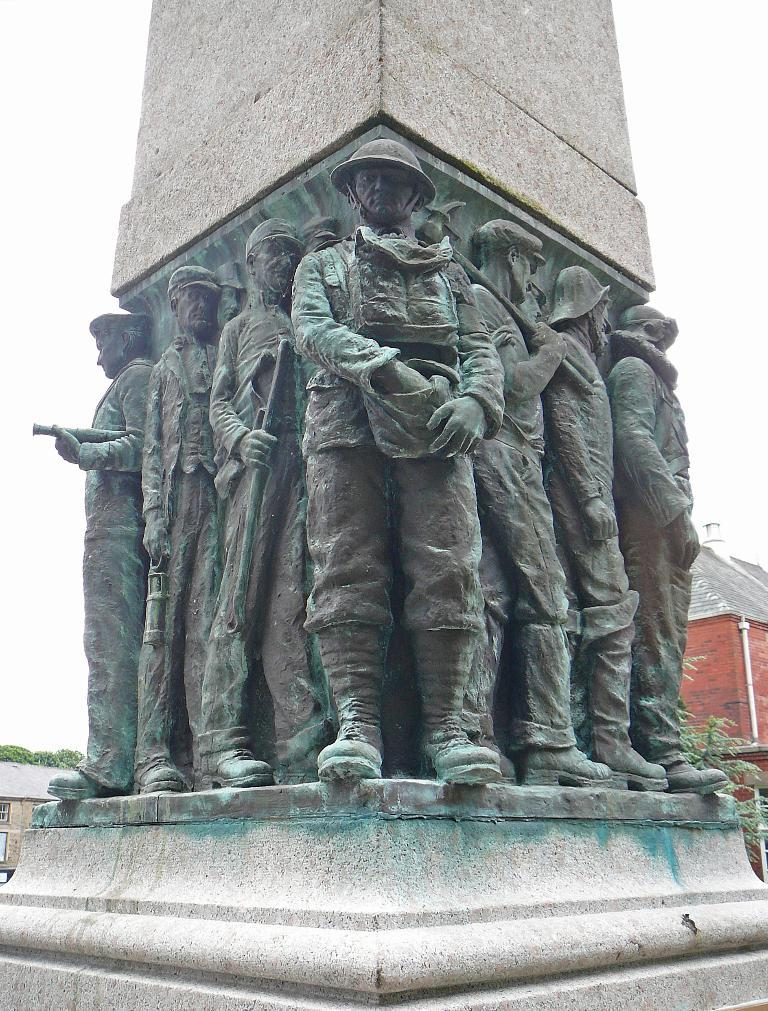What can be seen on the tower in the image? There are statues of persons on the tower. What type of vegetation is visible in the background of the image? There are plants in the background of the image. What type of structures can be seen in the background of the image? There are buildings in the background of the image. What is attached to the wall in the background of the image? There is a pipe on the wall in the background of the image. What is visible above the structures in the image? The sky is visible in the background of the image. What type of advertisement can be seen on the tower in the image? There is no advertisement present on the tower in the image; it features statues of persons. What type of fiction is depicted in the image? The image does not depict any fiction; it shows statues on a tower, plants, buildings, a pipe, and the sky. 